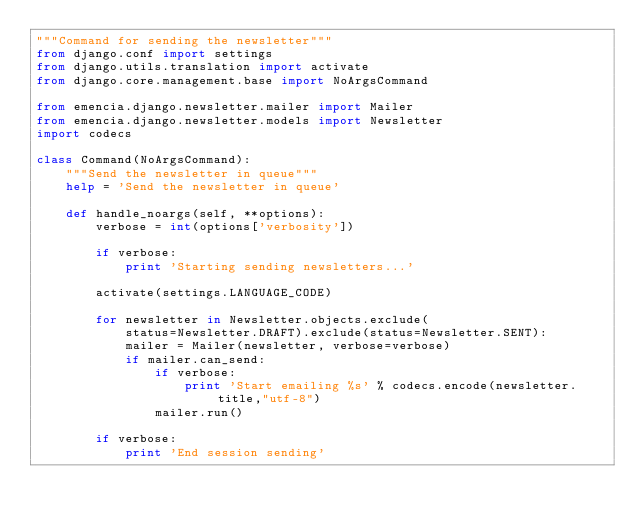<code> <loc_0><loc_0><loc_500><loc_500><_Python_>"""Command for sending the newsletter"""
from django.conf import settings
from django.utils.translation import activate
from django.core.management.base import NoArgsCommand

from emencia.django.newsletter.mailer import Mailer
from emencia.django.newsletter.models import Newsletter
import codecs

class Command(NoArgsCommand):
    """Send the newsletter in queue"""
    help = 'Send the newsletter in queue'

    def handle_noargs(self, **options):
        verbose = int(options['verbosity'])

        if verbose:
            print 'Starting sending newsletters...'

        activate(settings.LANGUAGE_CODE)

        for newsletter in Newsletter.objects.exclude(
            status=Newsletter.DRAFT).exclude(status=Newsletter.SENT):
            mailer = Mailer(newsletter, verbose=verbose)
            if mailer.can_send:
                if verbose:
                    print 'Start emailing %s' % codecs.encode(newsletter.title,"utf-8")
                mailer.run()

        if verbose:
            print 'End session sending'
</code> 